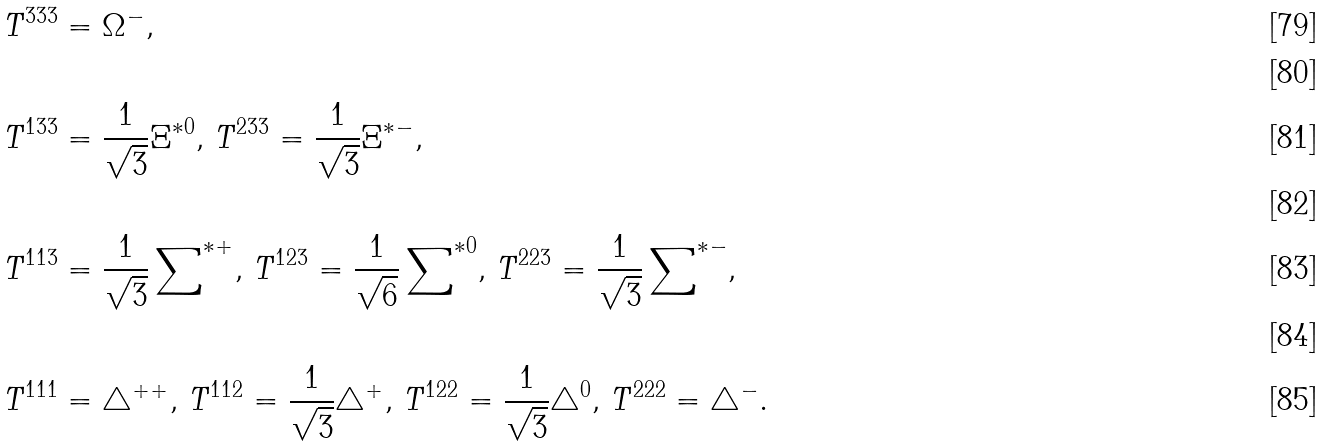<formula> <loc_0><loc_0><loc_500><loc_500>T ^ { 3 3 3 } & = \Omega ^ { - } , \\ \\ T ^ { 1 3 3 } & = \frac { 1 } { \sqrt { 3 } } \Xi ^ { \ast 0 } , \, T ^ { 2 3 3 } = \frac { 1 } { \sqrt { 3 } } \Xi ^ { \ast - } , \\ \\ T ^ { 1 1 3 } & = \frac { 1 } { \sqrt { 3 } } \sum \nolimits ^ { \ast + } , \, T ^ { 1 2 3 } = \frac { 1 } { \sqrt { 6 } } \sum \nolimits ^ { \ast 0 } , \, T ^ { 2 2 3 } = \frac { 1 } { \sqrt { 3 } } \sum \nolimits ^ { \ast - } , \\ \\ T ^ { 1 1 1 } & = \bigtriangleup ^ { + + } , \, T ^ { 1 1 2 } = \frac { 1 } { \sqrt { 3 } } \bigtriangleup ^ { + } , \, T ^ { 1 2 2 } = \frac { 1 } { \sqrt { 3 } } \bigtriangleup ^ { 0 } , \, T ^ { 2 2 2 } = \bigtriangleup ^ { - } .</formula> 